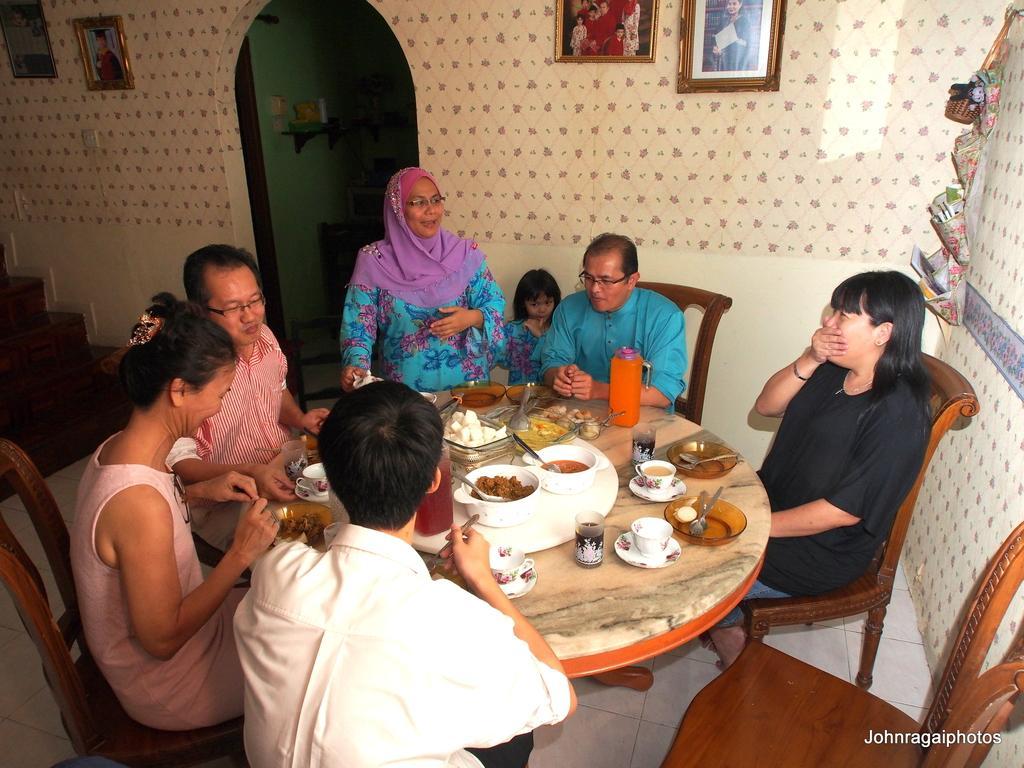Can you describe this image briefly? This picture is clicked inside the room. Here, we see many people sitting in chair and having their food. In front of them, we see a dining table on which cup, saucer, bowl, spoon, plate, food, water bottle is placed on it. Behind them, we see a wall on which two photo frames are placed on it and on the left top of the picture, we even see two more frames. Beside that, we see another room and on the left middle of the picture, we see staircase. 